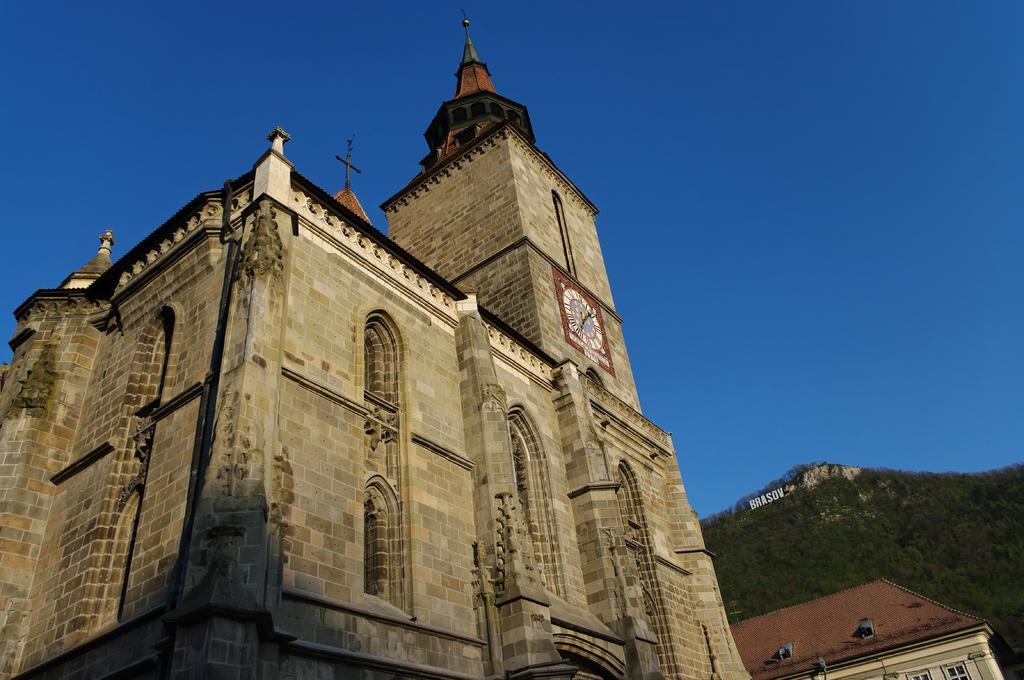Can you describe this image briefly? In this image there is a building having a clock attached to the wall. Right bottom there is a building. Behind there is a hill having few trees on it. Top of the image there is sky. 